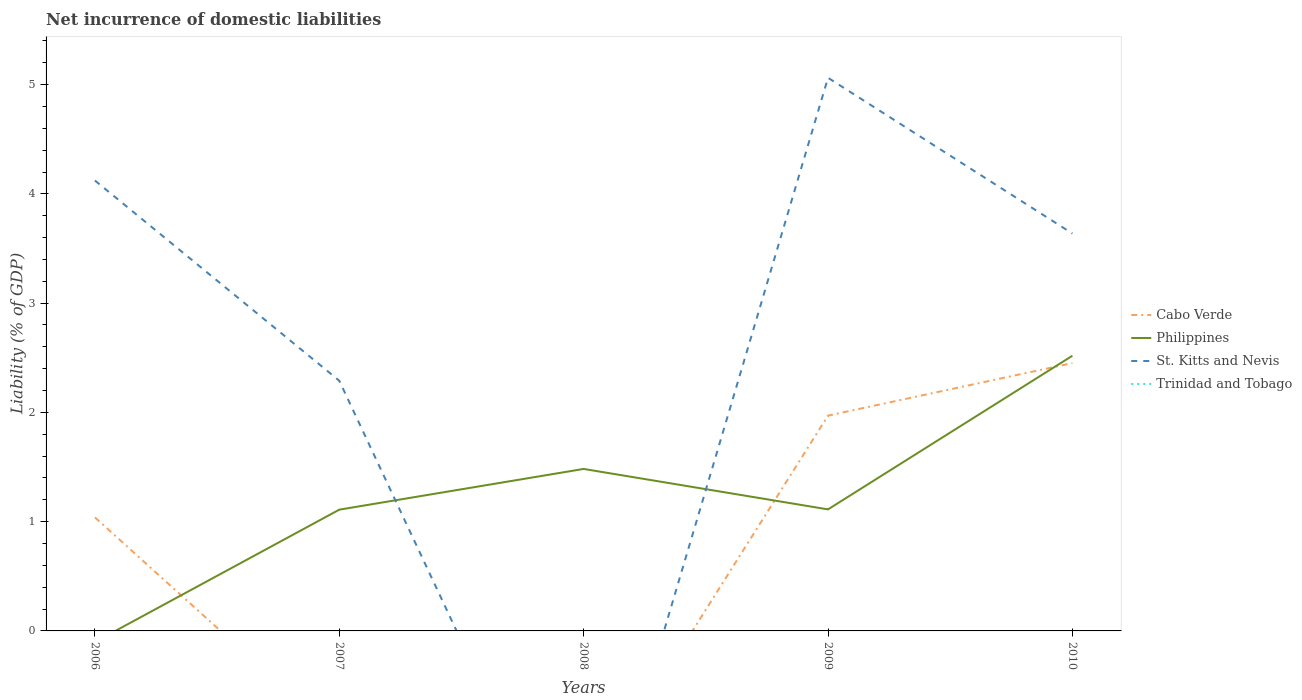How many different coloured lines are there?
Provide a short and direct response. 3. Is the number of lines equal to the number of legend labels?
Your response must be concise. No. Across all years, what is the maximum net incurrence of domestic liabilities in Cabo Verde?
Provide a short and direct response. 0. What is the total net incurrence of domestic liabilities in Cabo Verde in the graph?
Keep it short and to the point. -0.48. What is the difference between the highest and the second highest net incurrence of domestic liabilities in St. Kitts and Nevis?
Offer a terse response. 5.06. Is the net incurrence of domestic liabilities in Trinidad and Tobago strictly greater than the net incurrence of domestic liabilities in Philippines over the years?
Offer a very short reply. Yes. How many lines are there?
Offer a terse response. 3. How many years are there in the graph?
Keep it short and to the point. 5. What is the difference between two consecutive major ticks on the Y-axis?
Provide a short and direct response. 1. Does the graph contain grids?
Keep it short and to the point. No. Where does the legend appear in the graph?
Your response must be concise. Center right. How many legend labels are there?
Offer a very short reply. 4. What is the title of the graph?
Your answer should be very brief. Net incurrence of domestic liabilities. What is the label or title of the Y-axis?
Your response must be concise. Liability (% of GDP). What is the Liability (% of GDP) in Cabo Verde in 2006?
Offer a very short reply. 1.04. What is the Liability (% of GDP) in St. Kitts and Nevis in 2006?
Provide a succinct answer. 4.12. What is the Liability (% of GDP) in Trinidad and Tobago in 2006?
Your response must be concise. 0. What is the Liability (% of GDP) of Cabo Verde in 2007?
Provide a succinct answer. 0. What is the Liability (% of GDP) of Philippines in 2007?
Your response must be concise. 1.11. What is the Liability (% of GDP) of St. Kitts and Nevis in 2007?
Ensure brevity in your answer.  2.29. What is the Liability (% of GDP) of Trinidad and Tobago in 2007?
Keep it short and to the point. 0. What is the Liability (% of GDP) in Philippines in 2008?
Your response must be concise. 1.48. What is the Liability (% of GDP) in Trinidad and Tobago in 2008?
Provide a succinct answer. 0. What is the Liability (% of GDP) of Cabo Verde in 2009?
Give a very brief answer. 1.97. What is the Liability (% of GDP) in Philippines in 2009?
Your answer should be compact. 1.11. What is the Liability (% of GDP) in St. Kitts and Nevis in 2009?
Provide a short and direct response. 5.06. What is the Liability (% of GDP) in Cabo Verde in 2010?
Provide a succinct answer. 2.45. What is the Liability (% of GDP) in Philippines in 2010?
Give a very brief answer. 2.52. What is the Liability (% of GDP) of St. Kitts and Nevis in 2010?
Your answer should be compact. 3.64. Across all years, what is the maximum Liability (% of GDP) of Cabo Verde?
Your answer should be compact. 2.45. Across all years, what is the maximum Liability (% of GDP) in Philippines?
Offer a very short reply. 2.52. Across all years, what is the maximum Liability (% of GDP) in St. Kitts and Nevis?
Keep it short and to the point. 5.06. Across all years, what is the minimum Liability (% of GDP) of Cabo Verde?
Provide a succinct answer. 0. Across all years, what is the minimum Liability (% of GDP) of St. Kitts and Nevis?
Offer a very short reply. 0. What is the total Liability (% of GDP) of Cabo Verde in the graph?
Offer a terse response. 5.46. What is the total Liability (% of GDP) of Philippines in the graph?
Offer a very short reply. 6.22. What is the total Liability (% of GDP) in St. Kitts and Nevis in the graph?
Make the answer very short. 15.11. What is the total Liability (% of GDP) in Trinidad and Tobago in the graph?
Provide a short and direct response. 0. What is the difference between the Liability (% of GDP) in St. Kitts and Nevis in 2006 and that in 2007?
Offer a very short reply. 1.83. What is the difference between the Liability (% of GDP) in Cabo Verde in 2006 and that in 2009?
Offer a very short reply. -0.93. What is the difference between the Liability (% of GDP) of St. Kitts and Nevis in 2006 and that in 2009?
Give a very brief answer. -0.94. What is the difference between the Liability (% of GDP) in Cabo Verde in 2006 and that in 2010?
Make the answer very short. -1.41. What is the difference between the Liability (% of GDP) in St. Kitts and Nevis in 2006 and that in 2010?
Your response must be concise. 0.49. What is the difference between the Liability (% of GDP) in Philippines in 2007 and that in 2008?
Make the answer very short. -0.37. What is the difference between the Liability (% of GDP) in Philippines in 2007 and that in 2009?
Your answer should be very brief. -0. What is the difference between the Liability (% of GDP) of St. Kitts and Nevis in 2007 and that in 2009?
Ensure brevity in your answer.  -2.77. What is the difference between the Liability (% of GDP) of Philippines in 2007 and that in 2010?
Give a very brief answer. -1.41. What is the difference between the Liability (% of GDP) in St. Kitts and Nevis in 2007 and that in 2010?
Your answer should be compact. -1.35. What is the difference between the Liability (% of GDP) in Philippines in 2008 and that in 2009?
Provide a succinct answer. 0.37. What is the difference between the Liability (% of GDP) of Philippines in 2008 and that in 2010?
Ensure brevity in your answer.  -1.04. What is the difference between the Liability (% of GDP) of Cabo Verde in 2009 and that in 2010?
Make the answer very short. -0.48. What is the difference between the Liability (% of GDP) of Philippines in 2009 and that in 2010?
Offer a very short reply. -1.41. What is the difference between the Liability (% of GDP) in St. Kitts and Nevis in 2009 and that in 2010?
Ensure brevity in your answer.  1.43. What is the difference between the Liability (% of GDP) in Cabo Verde in 2006 and the Liability (% of GDP) in Philippines in 2007?
Offer a terse response. -0.07. What is the difference between the Liability (% of GDP) of Cabo Verde in 2006 and the Liability (% of GDP) of St. Kitts and Nevis in 2007?
Provide a short and direct response. -1.25. What is the difference between the Liability (% of GDP) of Cabo Verde in 2006 and the Liability (% of GDP) of Philippines in 2008?
Keep it short and to the point. -0.44. What is the difference between the Liability (% of GDP) in Cabo Verde in 2006 and the Liability (% of GDP) in Philippines in 2009?
Your response must be concise. -0.07. What is the difference between the Liability (% of GDP) in Cabo Verde in 2006 and the Liability (% of GDP) in St. Kitts and Nevis in 2009?
Make the answer very short. -4.02. What is the difference between the Liability (% of GDP) of Cabo Verde in 2006 and the Liability (% of GDP) of Philippines in 2010?
Provide a short and direct response. -1.48. What is the difference between the Liability (% of GDP) in Cabo Verde in 2006 and the Liability (% of GDP) in St. Kitts and Nevis in 2010?
Provide a succinct answer. -2.6. What is the difference between the Liability (% of GDP) in Philippines in 2007 and the Liability (% of GDP) in St. Kitts and Nevis in 2009?
Make the answer very short. -3.95. What is the difference between the Liability (% of GDP) in Philippines in 2007 and the Liability (% of GDP) in St. Kitts and Nevis in 2010?
Give a very brief answer. -2.53. What is the difference between the Liability (% of GDP) of Philippines in 2008 and the Liability (% of GDP) of St. Kitts and Nevis in 2009?
Offer a terse response. -3.58. What is the difference between the Liability (% of GDP) of Philippines in 2008 and the Liability (% of GDP) of St. Kitts and Nevis in 2010?
Provide a short and direct response. -2.15. What is the difference between the Liability (% of GDP) in Cabo Verde in 2009 and the Liability (% of GDP) in Philippines in 2010?
Your answer should be very brief. -0.55. What is the difference between the Liability (% of GDP) in Cabo Verde in 2009 and the Liability (% of GDP) in St. Kitts and Nevis in 2010?
Your answer should be very brief. -1.67. What is the difference between the Liability (% of GDP) of Philippines in 2009 and the Liability (% of GDP) of St. Kitts and Nevis in 2010?
Ensure brevity in your answer.  -2.52. What is the average Liability (% of GDP) in Cabo Verde per year?
Ensure brevity in your answer.  1.09. What is the average Liability (% of GDP) in Philippines per year?
Provide a short and direct response. 1.24. What is the average Liability (% of GDP) of St. Kitts and Nevis per year?
Your answer should be very brief. 3.02. In the year 2006, what is the difference between the Liability (% of GDP) in Cabo Verde and Liability (% of GDP) in St. Kitts and Nevis?
Provide a short and direct response. -3.08. In the year 2007, what is the difference between the Liability (% of GDP) in Philippines and Liability (% of GDP) in St. Kitts and Nevis?
Give a very brief answer. -1.18. In the year 2009, what is the difference between the Liability (% of GDP) in Cabo Verde and Liability (% of GDP) in Philippines?
Provide a short and direct response. 0.86. In the year 2009, what is the difference between the Liability (% of GDP) in Cabo Verde and Liability (% of GDP) in St. Kitts and Nevis?
Provide a succinct answer. -3.09. In the year 2009, what is the difference between the Liability (% of GDP) of Philippines and Liability (% of GDP) of St. Kitts and Nevis?
Offer a very short reply. -3.95. In the year 2010, what is the difference between the Liability (% of GDP) of Cabo Verde and Liability (% of GDP) of Philippines?
Make the answer very short. -0.07. In the year 2010, what is the difference between the Liability (% of GDP) of Cabo Verde and Liability (% of GDP) of St. Kitts and Nevis?
Give a very brief answer. -1.19. In the year 2010, what is the difference between the Liability (% of GDP) in Philippines and Liability (% of GDP) in St. Kitts and Nevis?
Ensure brevity in your answer.  -1.12. What is the ratio of the Liability (% of GDP) of St. Kitts and Nevis in 2006 to that in 2007?
Your answer should be very brief. 1.8. What is the ratio of the Liability (% of GDP) of Cabo Verde in 2006 to that in 2009?
Provide a succinct answer. 0.53. What is the ratio of the Liability (% of GDP) in St. Kitts and Nevis in 2006 to that in 2009?
Make the answer very short. 0.81. What is the ratio of the Liability (% of GDP) of Cabo Verde in 2006 to that in 2010?
Give a very brief answer. 0.42. What is the ratio of the Liability (% of GDP) in St. Kitts and Nevis in 2006 to that in 2010?
Your answer should be compact. 1.13. What is the ratio of the Liability (% of GDP) of Philippines in 2007 to that in 2008?
Offer a very short reply. 0.75. What is the ratio of the Liability (% of GDP) of Philippines in 2007 to that in 2009?
Provide a short and direct response. 1. What is the ratio of the Liability (% of GDP) in St. Kitts and Nevis in 2007 to that in 2009?
Ensure brevity in your answer.  0.45. What is the ratio of the Liability (% of GDP) of Philippines in 2007 to that in 2010?
Keep it short and to the point. 0.44. What is the ratio of the Liability (% of GDP) of St. Kitts and Nevis in 2007 to that in 2010?
Make the answer very short. 0.63. What is the ratio of the Liability (% of GDP) of Philippines in 2008 to that in 2009?
Offer a very short reply. 1.33. What is the ratio of the Liability (% of GDP) of Philippines in 2008 to that in 2010?
Ensure brevity in your answer.  0.59. What is the ratio of the Liability (% of GDP) in Cabo Verde in 2009 to that in 2010?
Make the answer very short. 0.8. What is the ratio of the Liability (% of GDP) in Philippines in 2009 to that in 2010?
Ensure brevity in your answer.  0.44. What is the ratio of the Liability (% of GDP) of St. Kitts and Nevis in 2009 to that in 2010?
Give a very brief answer. 1.39. What is the difference between the highest and the second highest Liability (% of GDP) of Cabo Verde?
Make the answer very short. 0.48. What is the difference between the highest and the second highest Liability (% of GDP) in Philippines?
Keep it short and to the point. 1.04. What is the difference between the highest and the second highest Liability (% of GDP) of St. Kitts and Nevis?
Provide a succinct answer. 0.94. What is the difference between the highest and the lowest Liability (% of GDP) of Cabo Verde?
Your answer should be compact. 2.45. What is the difference between the highest and the lowest Liability (% of GDP) of Philippines?
Your answer should be compact. 2.52. What is the difference between the highest and the lowest Liability (% of GDP) in St. Kitts and Nevis?
Your answer should be compact. 5.06. 